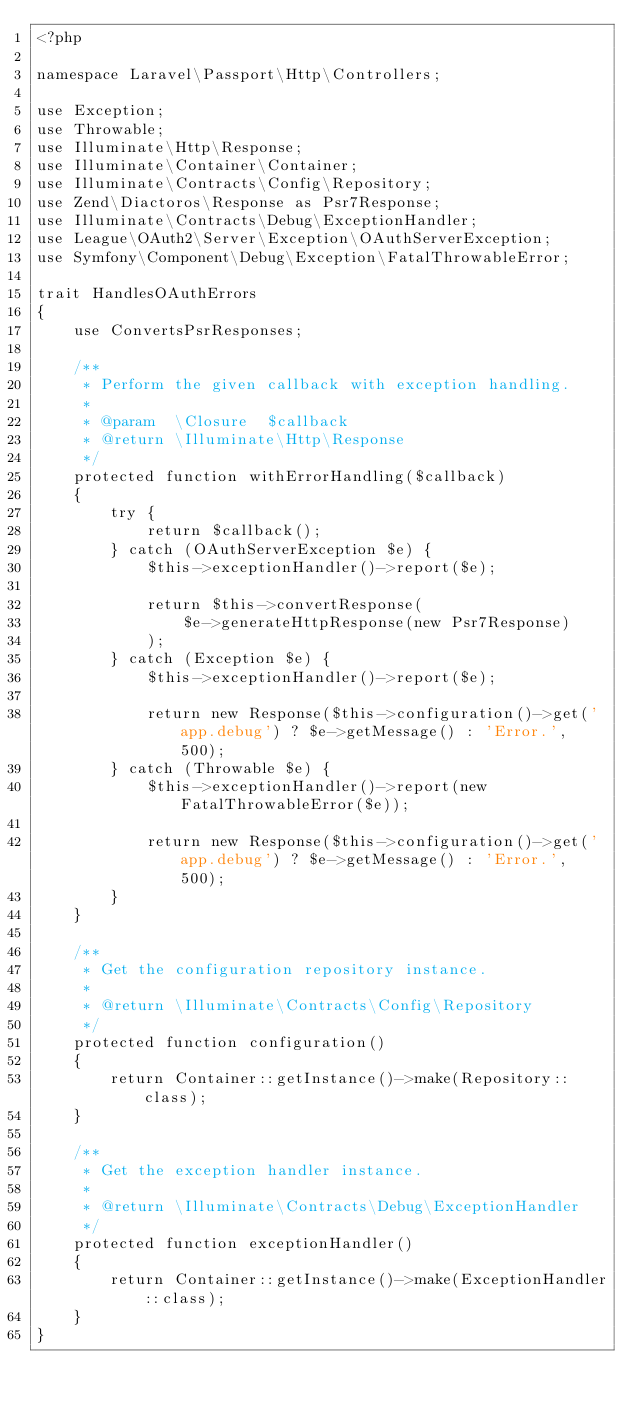<code> <loc_0><loc_0><loc_500><loc_500><_PHP_><?php

namespace Laravel\Passport\Http\Controllers;

use Exception;
use Throwable;
use Illuminate\Http\Response;
use Illuminate\Container\Container;
use Illuminate\Contracts\Config\Repository;
use Zend\Diactoros\Response as Psr7Response;
use Illuminate\Contracts\Debug\ExceptionHandler;
use League\OAuth2\Server\Exception\OAuthServerException;
use Symfony\Component\Debug\Exception\FatalThrowableError;

trait HandlesOAuthErrors
{
    use ConvertsPsrResponses;

    /**
     * Perform the given callback with exception handling.
     *
     * @param  \Closure  $callback
     * @return \Illuminate\Http\Response
     */
    protected function withErrorHandling($callback)
    {
        try {
            return $callback();
        } catch (OAuthServerException $e) {
            $this->exceptionHandler()->report($e);

            return $this->convertResponse(
                $e->generateHttpResponse(new Psr7Response)
            );
        } catch (Exception $e) {
            $this->exceptionHandler()->report($e);

            return new Response($this->configuration()->get('app.debug') ? $e->getMessage() : 'Error.', 500);
        } catch (Throwable $e) {
            $this->exceptionHandler()->report(new FatalThrowableError($e));

            return new Response($this->configuration()->get('app.debug') ? $e->getMessage() : 'Error.', 500);
        }
    }

    /**
     * Get the configuration repository instance.
     *
     * @return \Illuminate\Contracts\Config\Repository
     */
    protected function configuration()
    {
        return Container::getInstance()->make(Repository::class);
    }

    /**
     * Get the exception handler instance.
     *
     * @return \Illuminate\Contracts\Debug\ExceptionHandler
     */
    protected function exceptionHandler()
    {
        return Container::getInstance()->make(ExceptionHandler::class);
    }
}
</code> 